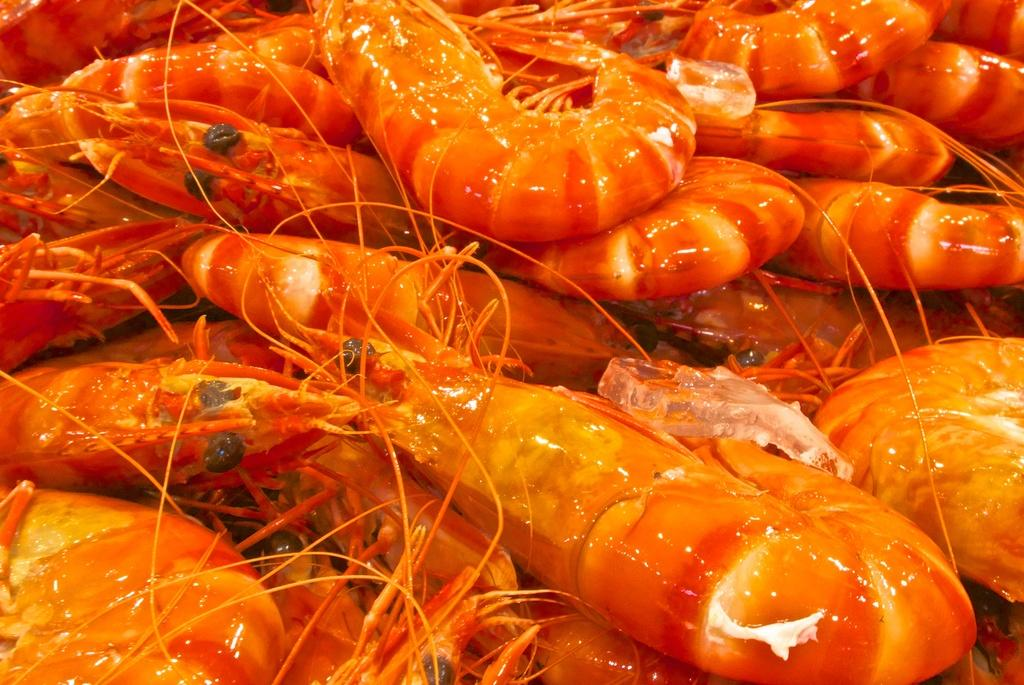What type of food is present in the image? There is seafood in the image. Can you describe the color of the seafood? The seafood is orange in color. What type of coach is depicted in the image? There is no coach present in the image; it features seafood. Who needs to approve the seafood in the image? The image does not require approval, as it is a static representation of seafood. 